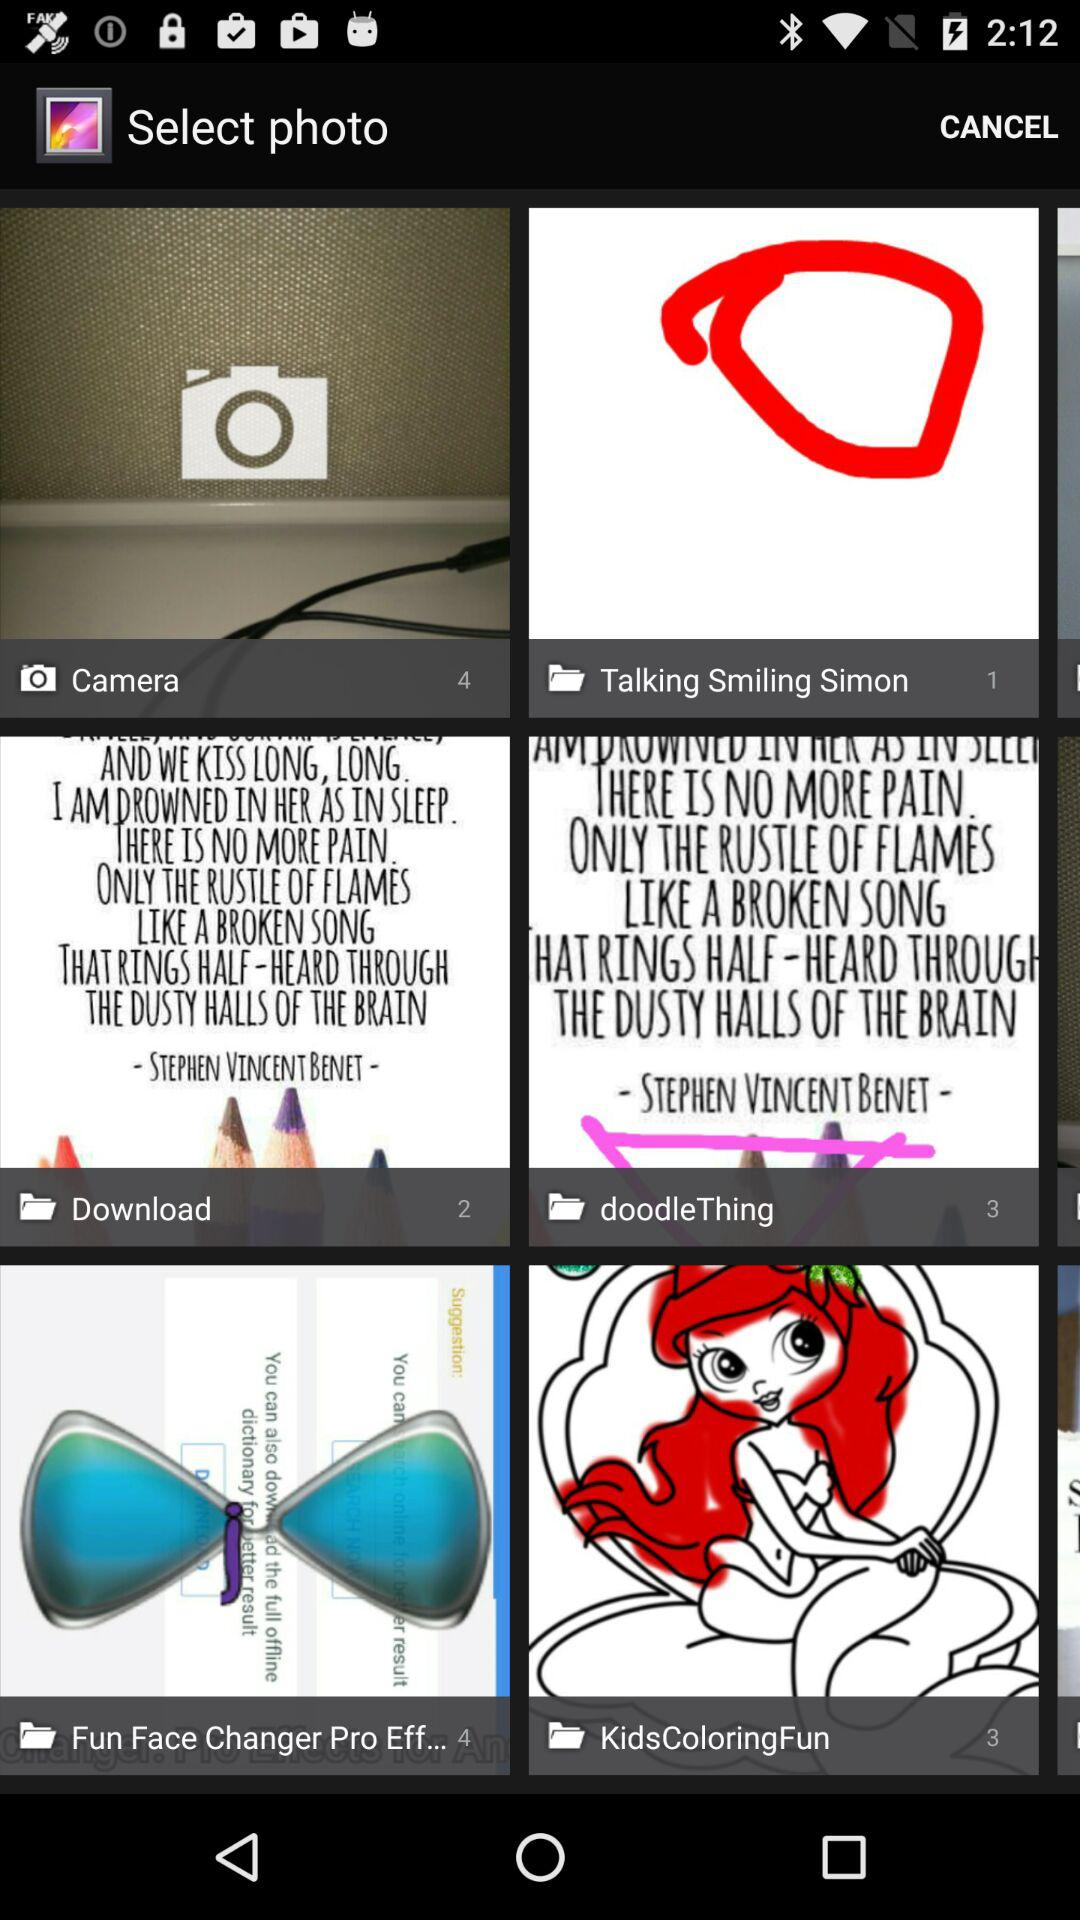How many photos are there in "Talking Smiling Simon"? There is 1 photo in "Talking Smiling Simon". 